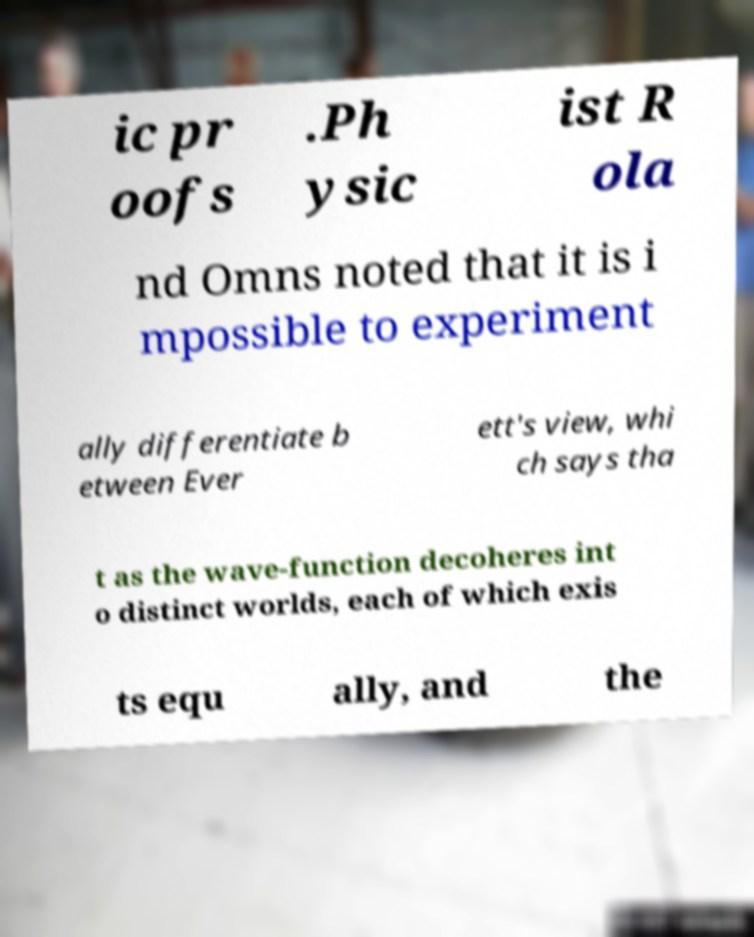Could you assist in decoding the text presented in this image and type it out clearly? ic pr oofs .Ph ysic ist R ola nd Omns noted that it is i mpossible to experiment ally differentiate b etween Ever ett's view, whi ch says tha t as the wave-function decoheres int o distinct worlds, each of which exis ts equ ally, and the 